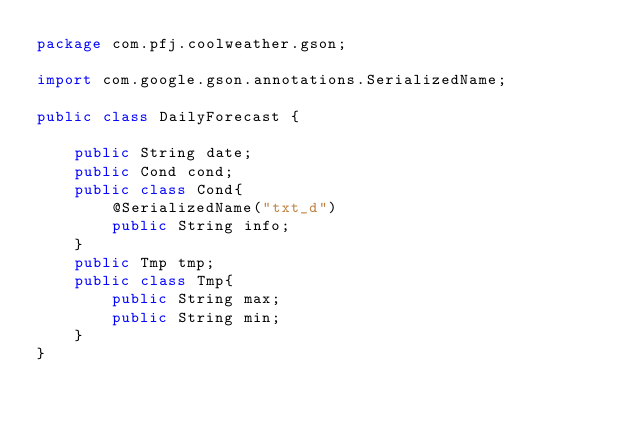<code> <loc_0><loc_0><loc_500><loc_500><_Java_>package com.pfj.coolweather.gson;

import com.google.gson.annotations.SerializedName;

public class DailyForecast {

    public String date;
    public Cond cond;
    public class Cond{
        @SerializedName("txt_d")
        public String info;
    }
    public Tmp tmp;
    public class Tmp{
        public String max;
        public String min;
    }
}
</code> 